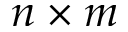Convert formula to latex. <formula><loc_0><loc_0><loc_500><loc_500>n \times m</formula> 